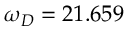<formula> <loc_0><loc_0><loc_500><loc_500>\omega _ { D } = 2 1 . 6 5 9</formula> 